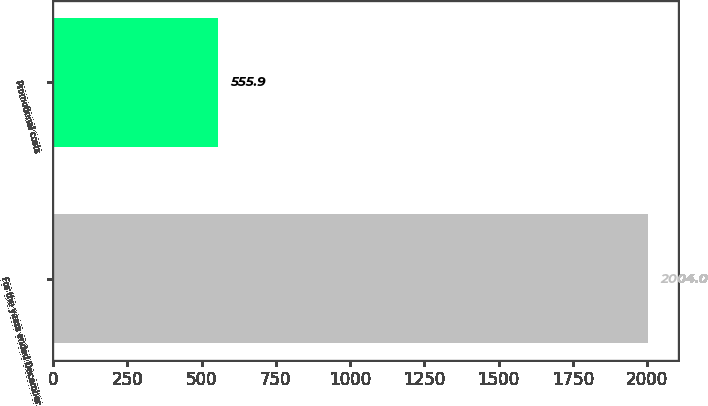Convert chart to OTSL. <chart><loc_0><loc_0><loc_500><loc_500><bar_chart><fcel>For the years ended December<fcel>Promotional costs<nl><fcel>2004<fcel>555.9<nl></chart> 